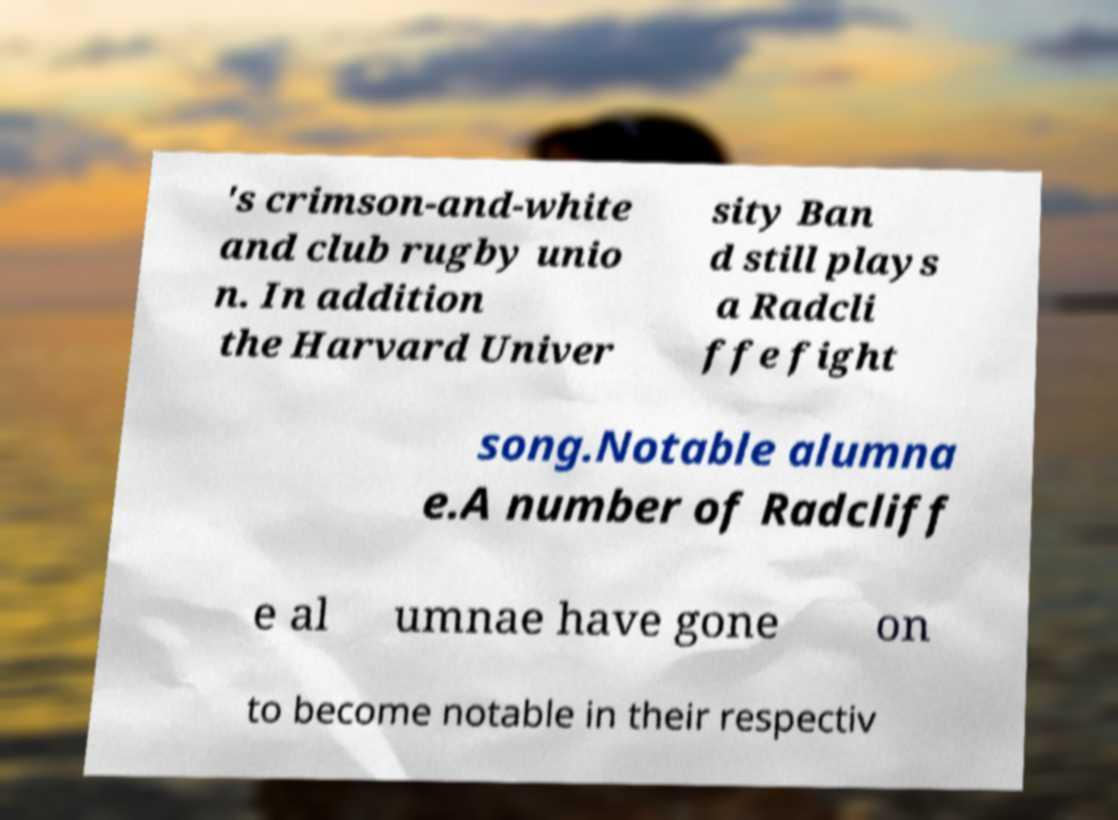I need the written content from this picture converted into text. Can you do that? 's crimson-and-white and club rugby unio n. In addition the Harvard Univer sity Ban d still plays a Radcli ffe fight song.Notable alumna e.A number of Radcliff e al umnae have gone on to become notable in their respectiv 